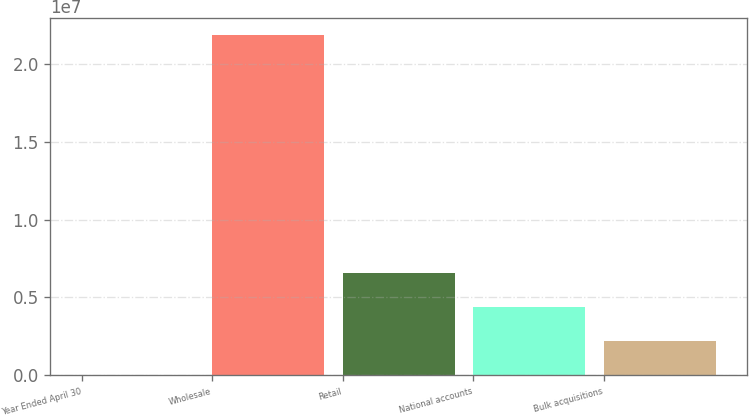<chart> <loc_0><loc_0><loc_500><loc_500><bar_chart><fcel>Year Ended April 30<fcel>Wholesale<fcel>Retail<fcel>National accounts<fcel>Bulk acquisitions<nl><fcel>2005<fcel>2.18418e+07<fcel>6.55394e+06<fcel>4.36996e+06<fcel>2.18598e+06<nl></chart> 